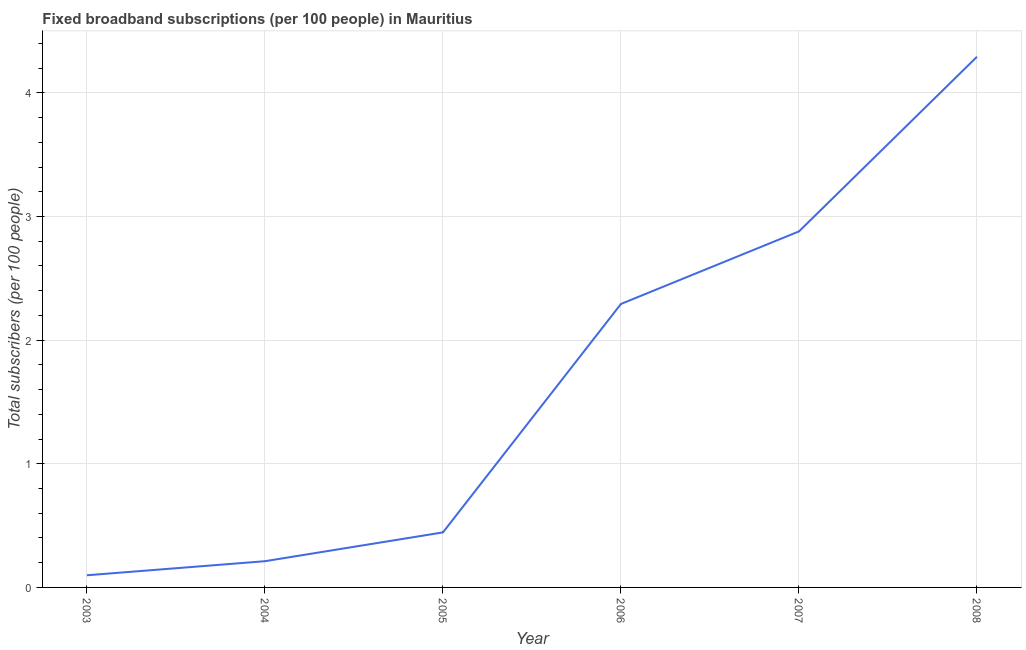What is the total number of fixed broadband subscriptions in 2006?
Your answer should be compact. 2.29. Across all years, what is the maximum total number of fixed broadband subscriptions?
Your answer should be compact. 4.29. Across all years, what is the minimum total number of fixed broadband subscriptions?
Keep it short and to the point. 0.1. In which year was the total number of fixed broadband subscriptions maximum?
Your response must be concise. 2008. What is the sum of the total number of fixed broadband subscriptions?
Give a very brief answer. 10.22. What is the difference between the total number of fixed broadband subscriptions in 2004 and 2005?
Offer a very short reply. -0.23. What is the average total number of fixed broadband subscriptions per year?
Offer a terse response. 1.7. What is the median total number of fixed broadband subscriptions?
Offer a terse response. 1.37. In how many years, is the total number of fixed broadband subscriptions greater than 2.6 ?
Ensure brevity in your answer.  2. Do a majority of the years between 2007 and 2008 (inclusive) have total number of fixed broadband subscriptions greater than 4 ?
Provide a succinct answer. No. What is the ratio of the total number of fixed broadband subscriptions in 2007 to that in 2008?
Offer a very short reply. 0.67. What is the difference between the highest and the second highest total number of fixed broadband subscriptions?
Offer a terse response. 1.41. What is the difference between the highest and the lowest total number of fixed broadband subscriptions?
Your answer should be very brief. 4.19. Does the total number of fixed broadband subscriptions monotonically increase over the years?
Keep it short and to the point. Yes. How many lines are there?
Make the answer very short. 1. How many years are there in the graph?
Your answer should be compact. 6. What is the difference between two consecutive major ticks on the Y-axis?
Keep it short and to the point. 1. Are the values on the major ticks of Y-axis written in scientific E-notation?
Offer a terse response. No. Does the graph contain grids?
Give a very brief answer. Yes. What is the title of the graph?
Provide a succinct answer. Fixed broadband subscriptions (per 100 people) in Mauritius. What is the label or title of the Y-axis?
Your answer should be very brief. Total subscribers (per 100 people). What is the Total subscribers (per 100 people) in 2003?
Ensure brevity in your answer.  0.1. What is the Total subscribers (per 100 people) in 2004?
Your answer should be compact. 0.21. What is the Total subscribers (per 100 people) of 2005?
Provide a short and direct response. 0.45. What is the Total subscribers (per 100 people) in 2006?
Keep it short and to the point. 2.29. What is the Total subscribers (per 100 people) of 2007?
Ensure brevity in your answer.  2.88. What is the Total subscribers (per 100 people) in 2008?
Keep it short and to the point. 4.29. What is the difference between the Total subscribers (per 100 people) in 2003 and 2004?
Keep it short and to the point. -0.11. What is the difference between the Total subscribers (per 100 people) in 2003 and 2005?
Provide a succinct answer. -0.35. What is the difference between the Total subscribers (per 100 people) in 2003 and 2006?
Provide a short and direct response. -2.19. What is the difference between the Total subscribers (per 100 people) in 2003 and 2007?
Make the answer very short. -2.78. What is the difference between the Total subscribers (per 100 people) in 2003 and 2008?
Your answer should be compact. -4.19. What is the difference between the Total subscribers (per 100 people) in 2004 and 2005?
Your response must be concise. -0.23. What is the difference between the Total subscribers (per 100 people) in 2004 and 2006?
Your answer should be very brief. -2.08. What is the difference between the Total subscribers (per 100 people) in 2004 and 2007?
Your response must be concise. -2.67. What is the difference between the Total subscribers (per 100 people) in 2004 and 2008?
Keep it short and to the point. -4.08. What is the difference between the Total subscribers (per 100 people) in 2005 and 2006?
Provide a succinct answer. -1.85. What is the difference between the Total subscribers (per 100 people) in 2005 and 2007?
Ensure brevity in your answer.  -2.43. What is the difference between the Total subscribers (per 100 people) in 2005 and 2008?
Your response must be concise. -3.85. What is the difference between the Total subscribers (per 100 people) in 2006 and 2007?
Provide a short and direct response. -0.59. What is the difference between the Total subscribers (per 100 people) in 2006 and 2008?
Make the answer very short. -2. What is the difference between the Total subscribers (per 100 people) in 2007 and 2008?
Keep it short and to the point. -1.41. What is the ratio of the Total subscribers (per 100 people) in 2003 to that in 2004?
Give a very brief answer. 0.46. What is the ratio of the Total subscribers (per 100 people) in 2003 to that in 2005?
Make the answer very short. 0.22. What is the ratio of the Total subscribers (per 100 people) in 2003 to that in 2006?
Give a very brief answer. 0.04. What is the ratio of the Total subscribers (per 100 people) in 2003 to that in 2007?
Give a very brief answer. 0.03. What is the ratio of the Total subscribers (per 100 people) in 2003 to that in 2008?
Ensure brevity in your answer.  0.02. What is the ratio of the Total subscribers (per 100 people) in 2004 to that in 2005?
Give a very brief answer. 0.48. What is the ratio of the Total subscribers (per 100 people) in 2004 to that in 2006?
Offer a very short reply. 0.09. What is the ratio of the Total subscribers (per 100 people) in 2004 to that in 2007?
Give a very brief answer. 0.07. What is the ratio of the Total subscribers (per 100 people) in 2004 to that in 2008?
Ensure brevity in your answer.  0.05. What is the ratio of the Total subscribers (per 100 people) in 2005 to that in 2006?
Offer a terse response. 0.19. What is the ratio of the Total subscribers (per 100 people) in 2005 to that in 2007?
Offer a very short reply. 0.15. What is the ratio of the Total subscribers (per 100 people) in 2005 to that in 2008?
Provide a short and direct response. 0.1. What is the ratio of the Total subscribers (per 100 people) in 2006 to that in 2007?
Your answer should be very brief. 0.8. What is the ratio of the Total subscribers (per 100 people) in 2006 to that in 2008?
Ensure brevity in your answer.  0.53. What is the ratio of the Total subscribers (per 100 people) in 2007 to that in 2008?
Keep it short and to the point. 0.67. 